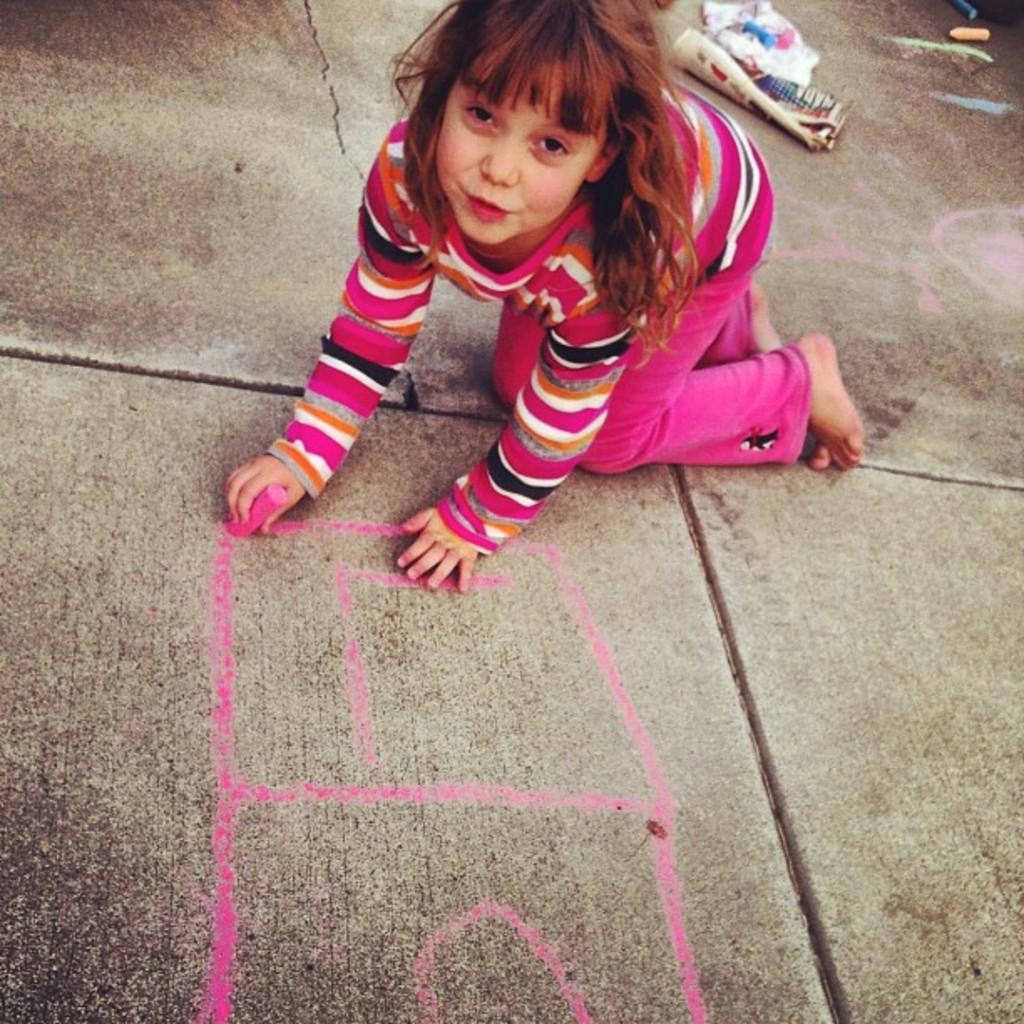Describe this image in one or two sentences. There is one kid is in a crawling position on the ground as we can see at the top of this image, and she is holding a piece of chalk. There are some objects kept on the ground at the top left side of this image. 